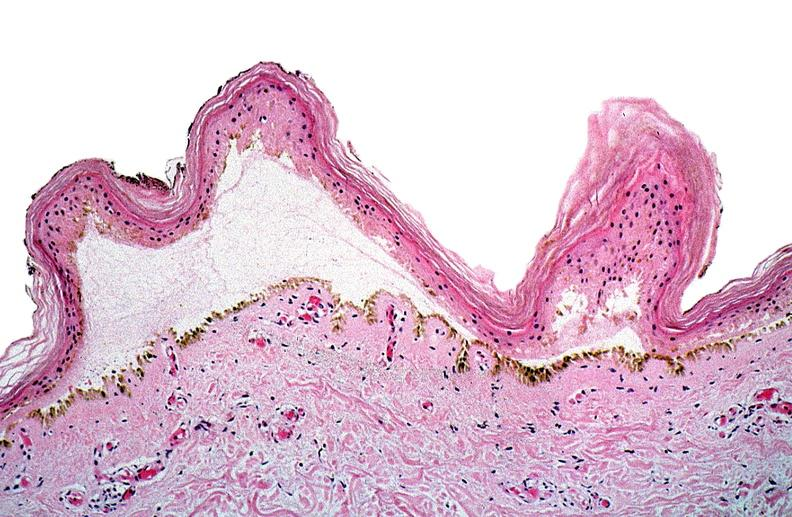does this image show thermal burned skin?
Answer the question using a single word or phrase. Yes 